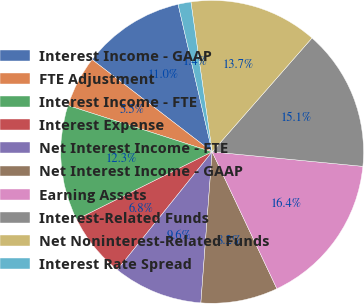<chart> <loc_0><loc_0><loc_500><loc_500><pie_chart><fcel>Interest Income - GAAP<fcel>FTE Adjustment<fcel>Interest Income - FTE<fcel>Interest Expense<fcel>Net Interest Income - FTE<fcel>Net Interest Income - GAAP<fcel>Earning Assets<fcel>Interest-Related Funds<fcel>Net Noninterest-Related Funds<fcel>Interest Rate Spread<nl><fcel>10.96%<fcel>5.48%<fcel>12.33%<fcel>6.85%<fcel>9.59%<fcel>8.22%<fcel>16.44%<fcel>15.07%<fcel>13.7%<fcel>1.37%<nl></chart> 